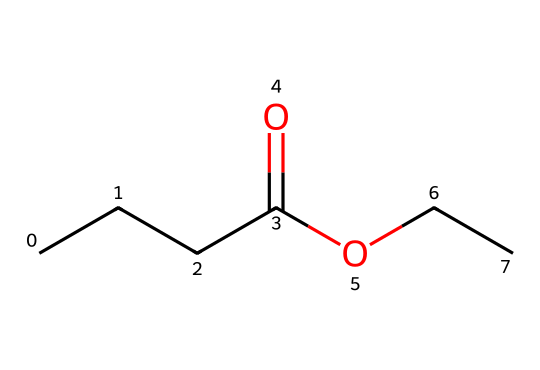What is the molecular formula of this compound? The SMILES representation CCCC(=O)OCC indicates that the compound has four carbons in the straight chain (CCCC), one carbon in the ethyl group (C), two oxygen atoms (O), and is therefore composed of 6 carbons, 12 hydrogens, and 2 oxygens.
Answer: C6H12O2 How many total carbon atoms are present in ethyl butyrate? By examining the SMILES notation, we count four carbons in the butyrate part (CCCC) and two in the ethyl group (CC). Adding these gives a total of six carbon atoms.
Answer: 6 What type of chemical is ethyl butyrate? The presence of the ester functional group (-O- and carbonyl group C(=O)) in the structure confirms that this compound is classified as an ester.
Answer: ester What is the functional group present in ethyl butyrate? The segment -O- corresponds to the functional group category, which is indicative of esters, combined with the carbonyl (C=O) indicates that the functional group present here is an ester functional group.
Answer: ester Which part of the molecule contributes to its fruity scent? The butyrate portion, specifically the carbon chain comprising four carbons (CCCC) contributes to the characteristic fruity scent of ethyl butyrate, typical of many esters.
Answer: butyrate 